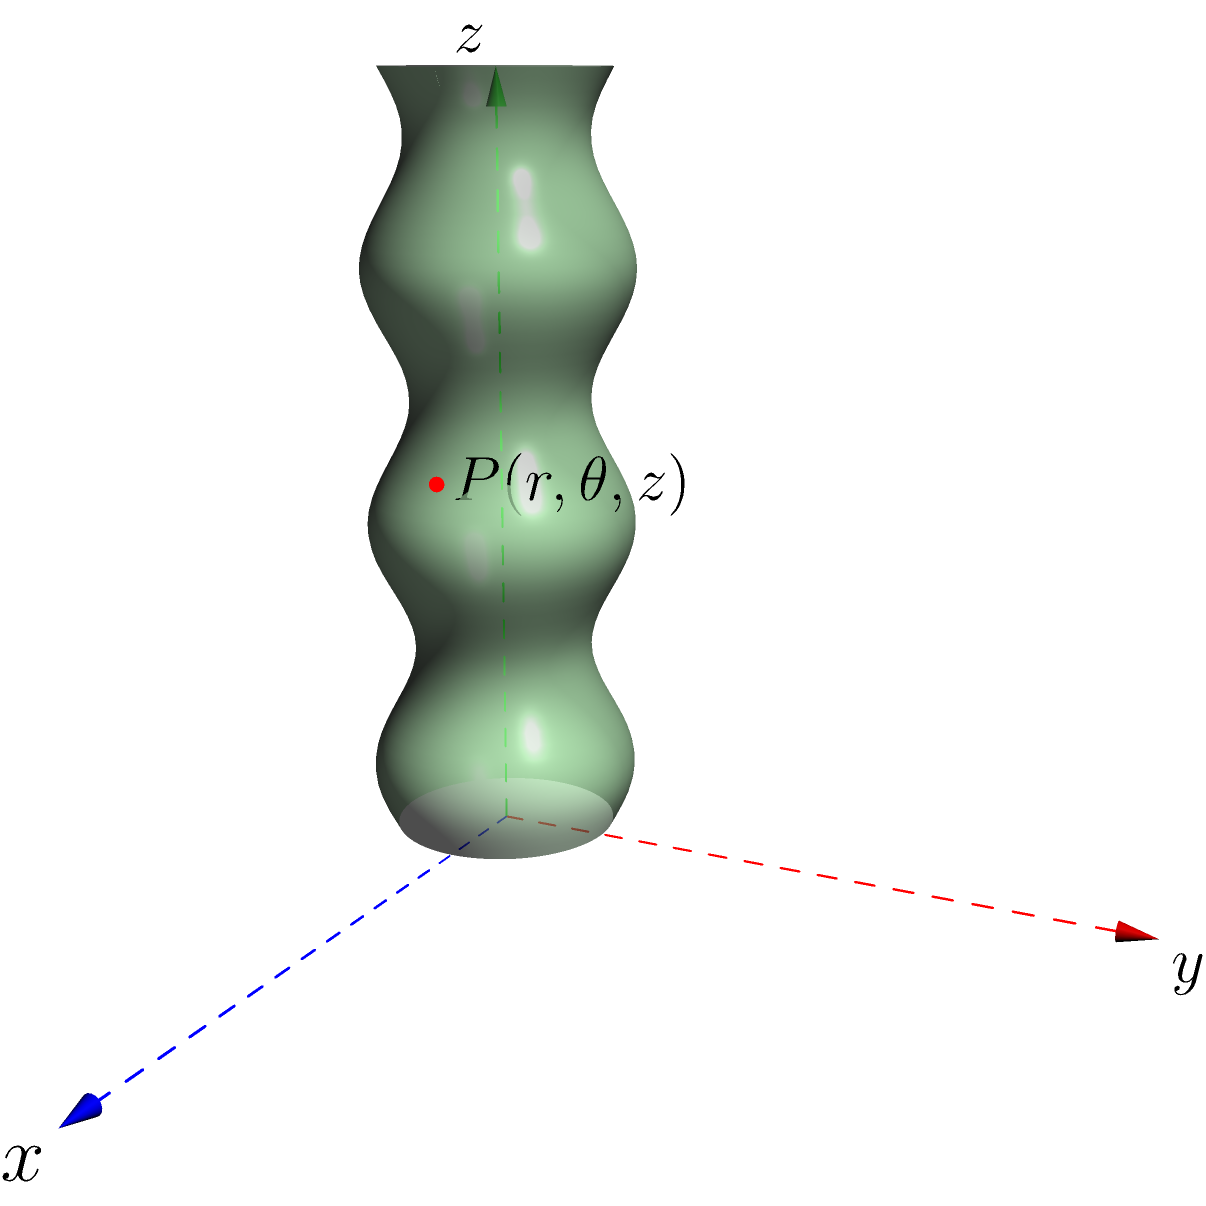Consider an elongated isopod species whose body can be modeled using cylindrical coordinates $(r,\theta,z)$. The radius $r$ of each body segment varies along the length of the isopod according to the function $r(z) = 0.5 + 0.1\sin(2\pi z)$, where $z$ represents the distance along the central axis of the isopod (in cm). If the total length of the isopod is 3 cm, what is the maximum variation in radius along its body? To find the maximum variation in radius along the isopod's body, we need to follow these steps:

1) The radius function is given as $r(z) = 0.5 + 0.1\sin(2\pi z)$

2) To find the maximum and minimum radii, we need to consider the extreme values of the sine function:
   - $\sin(2\pi z)$ has a maximum value of 1 and a minimum value of -1

3) Maximum radius occurs when $\sin(2\pi z) = 1$:
   $r_{max} = 0.5 + 0.1(1) = 0.6$ cm

4) Minimum radius occurs when $\sin(2\pi z) = -1$:
   $r_{min} = 0.5 + 0.1(-1) = 0.4$ cm

5) The maximum variation in radius is the difference between the maximum and minimum radii:
   Variation = $r_{max} - r_{min} = 0.6 - 0.4 = 0.2$ cm

Therefore, the maximum variation in radius along the isopod's body is 0.2 cm.
Answer: 0.2 cm 